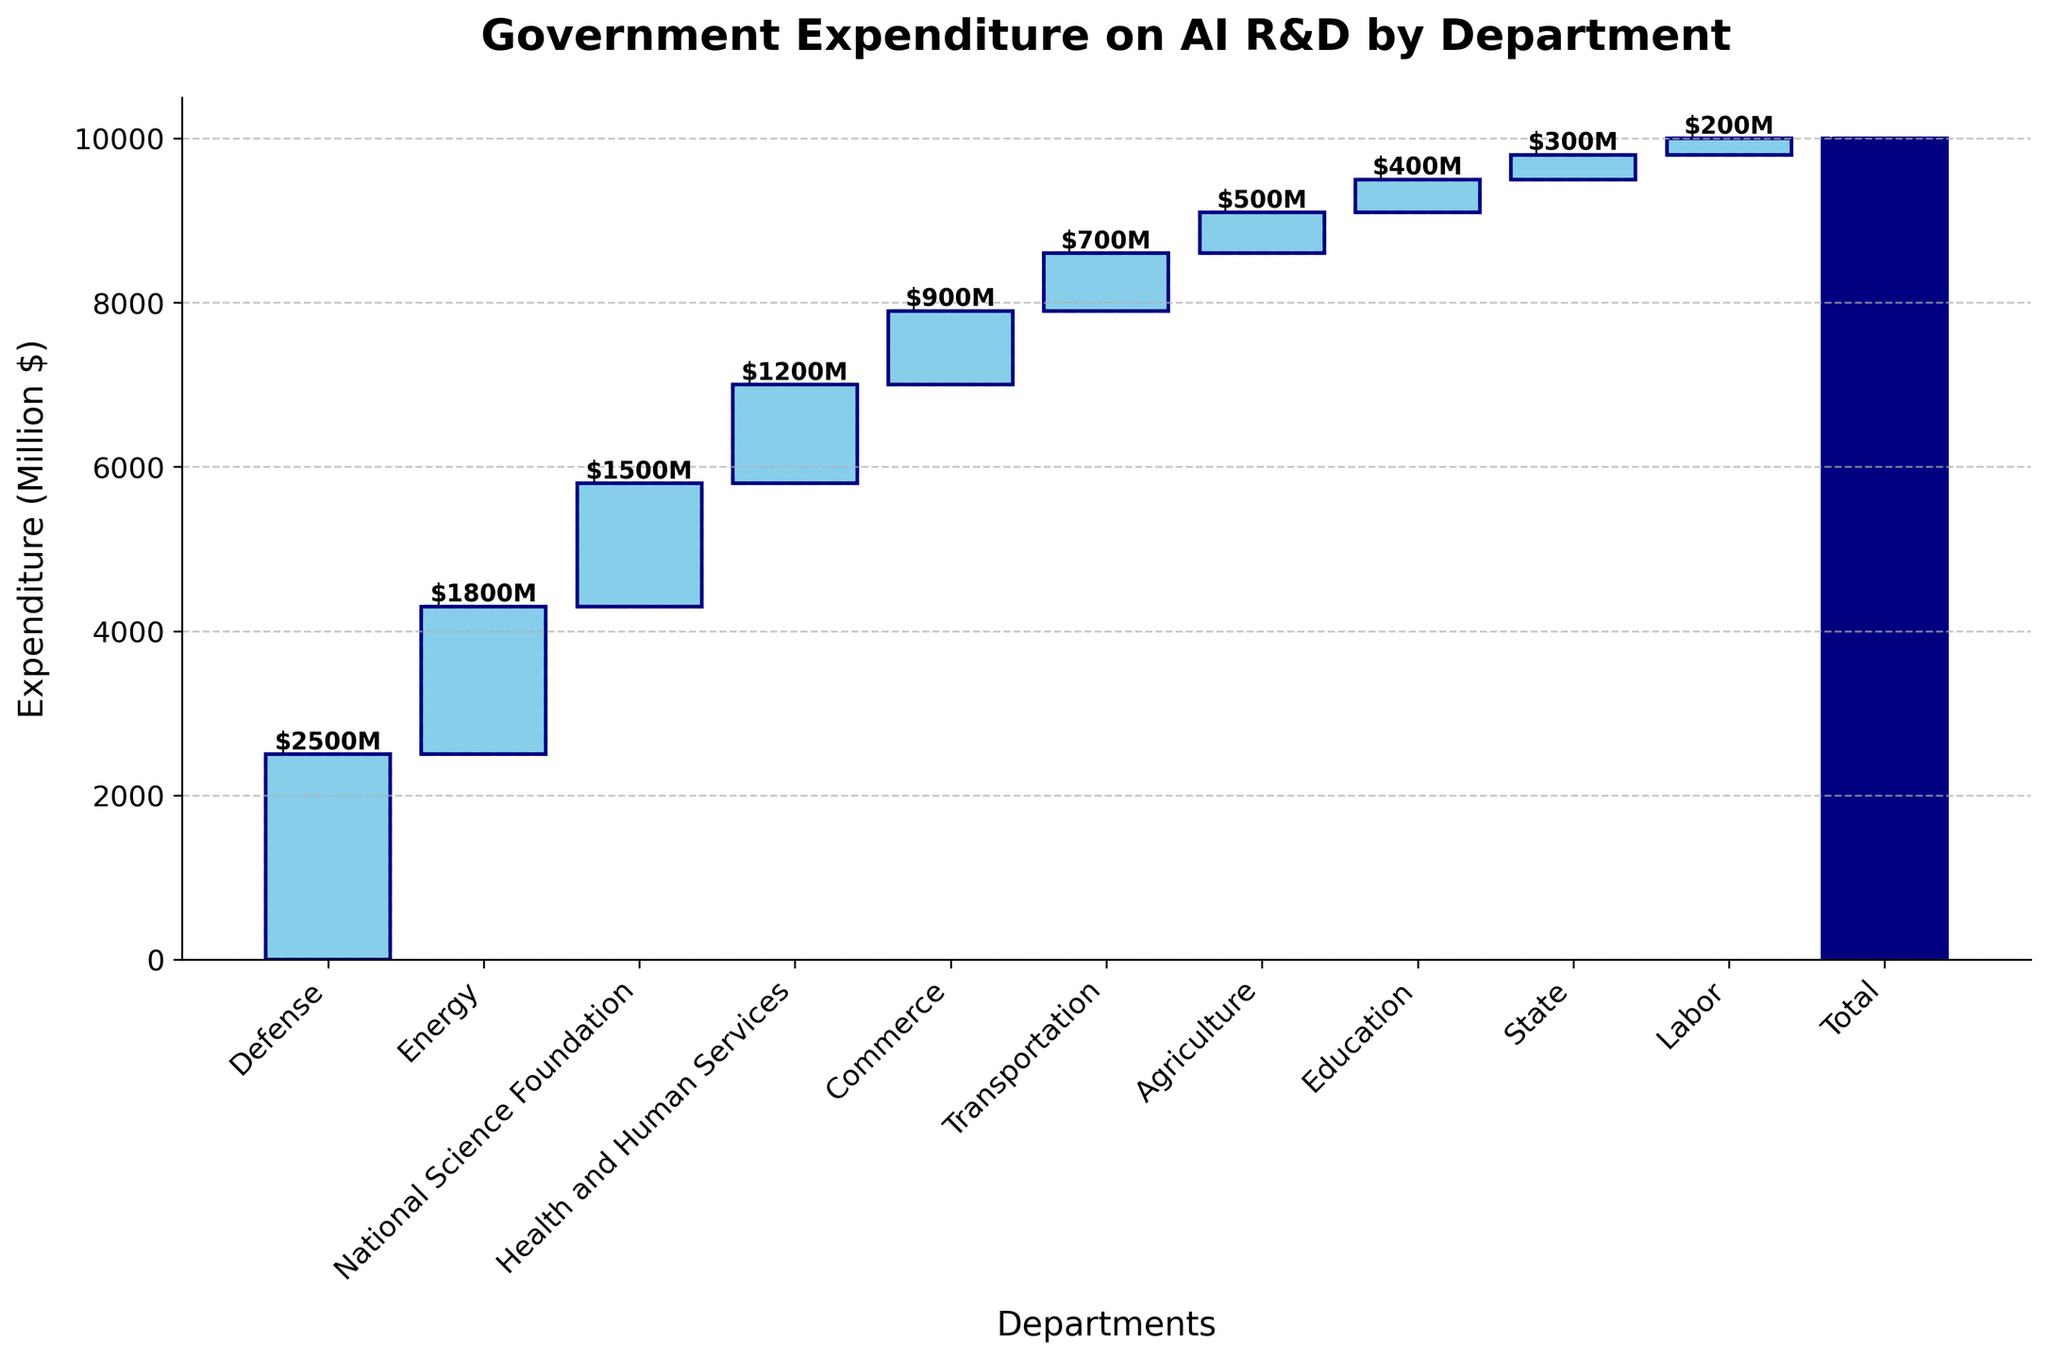What's the title of the figure? The title of the figure is located at the top and is presented in bold. It summarizes the content of the figure.
Answer: Government Expenditure on AI R&D by Department What is the total government expenditure on AI R&D? The total expenditure is represented by the "Total" bar, depicted at the last position on the x-axis. The value associated with it is shown on the bar.
Answer: $10000M Which department has the highest expenditure on AI R&D? By comparing all the departments' bars, the Defense department has the tallest bar, representing the highest expenditure.
Answer: Defense What is the combined expenditure of the Health and Human Services and Commerce departments? Sum the expenditures for the Health and Human Services ($1200M) and Commerce ($900M) departments.
Answer: $2100M How much more does the Defense department spend compared to the Transportation department? Subtract the Transportation department's expenditure ($700M) from the Defense department's expenditure ($2500M).
Answer: $1800M Which department has the lowest expenditure on AI R&D? The smallest bar on the chart belongs to the Labor department, indicating the lowest expenditure.
Answer: Labor What is the average expenditure of the Energy and Agriculture departments? Calculate the mean of the Energy department's expenditure ($1800M) and the Agriculture department's expenditure ($500M). The average is ($1800M + $500M) / 2.
Answer: $1150M What is the total expenditure of the departments excluding the Defense and Energy departments? Add the expenditures of the remaining departments excluding the Defense ($2500M) and Energy ($1800M). So, Health and Human Services ($1200M) + National Science Foundation ($1500M) + Commerce ($900M) + Transportation ($700M) + Agriculture ($500M) + Education ($400M) + State ($300M) + Labor ($200M).
Answer: $5700M Which department ranks third in terms of expenditure on AI R&D? The third-tallest bar, after Defense and Energy, corresponds to the National Science Foundation.
Answer: National Science Foundation Between the National Science Foundation and the State departments, which one spends more, and by how much? Subtract the State department's expenditure ($300M) from the National Science Foundation department's expenditure ($1500M).
Answer: National Science Foundation by $1200M 